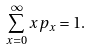<formula> <loc_0><loc_0><loc_500><loc_500>\sum _ { x = 0 } ^ { \infty } x p _ { x } = 1 .</formula> 